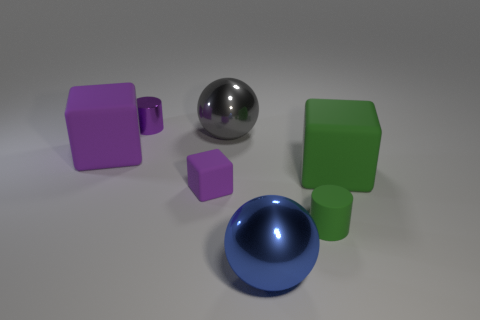Add 3 large purple objects. How many objects exist? 10 Subtract all tiny purple cubes. How many cubes are left? 2 Subtract 2 spheres. How many spheres are left? 0 Add 3 tiny blocks. How many tiny blocks are left? 4 Add 5 cyan rubber cylinders. How many cyan rubber cylinders exist? 5 Subtract all blue spheres. How many spheres are left? 1 Subtract 1 green cubes. How many objects are left? 6 Subtract all spheres. How many objects are left? 5 Subtract all gray spheres. Subtract all brown cylinders. How many spheres are left? 1 Subtract all green cylinders. How many yellow cubes are left? 0 